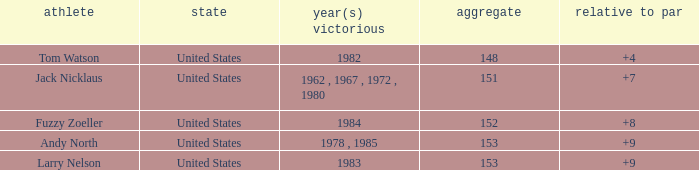What is the Country of the Player with a Total less than 153 and Year(s) won of 1984? United States. 